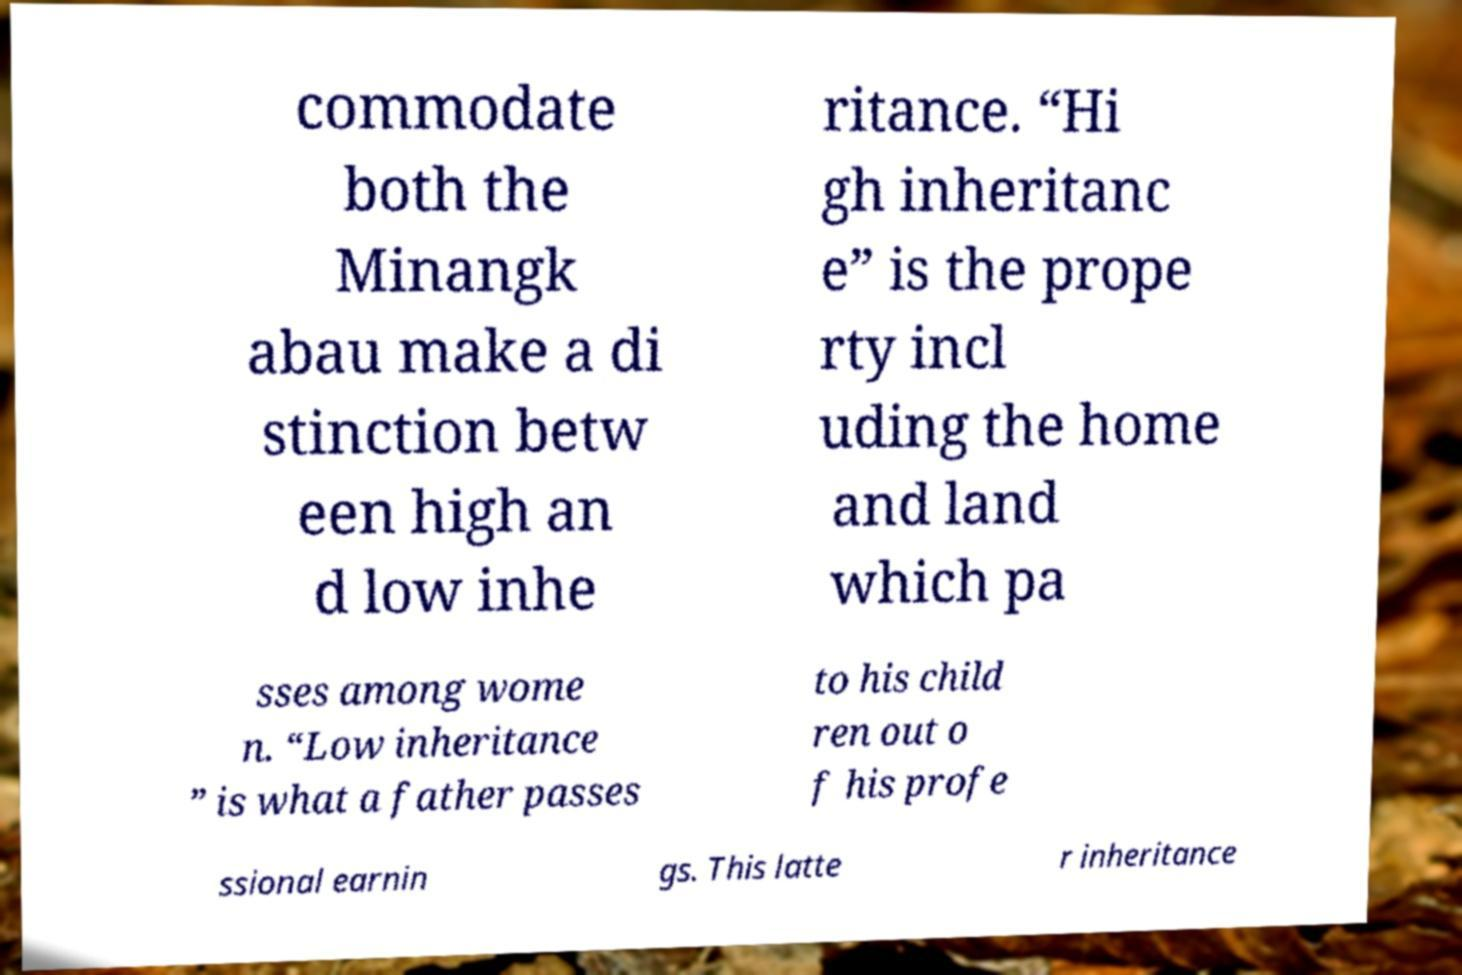For documentation purposes, I need the text within this image transcribed. Could you provide that? commodate both the Minangk abau make a di stinction betw een high an d low inhe ritance. “Hi gh inheritanc e” is the prope rty incl uding the home and land which pa sses among wome n. “Low inheritance ” is what a father passes to his child ren out o f his profe ssional earnin gs. This latte r inheritance 